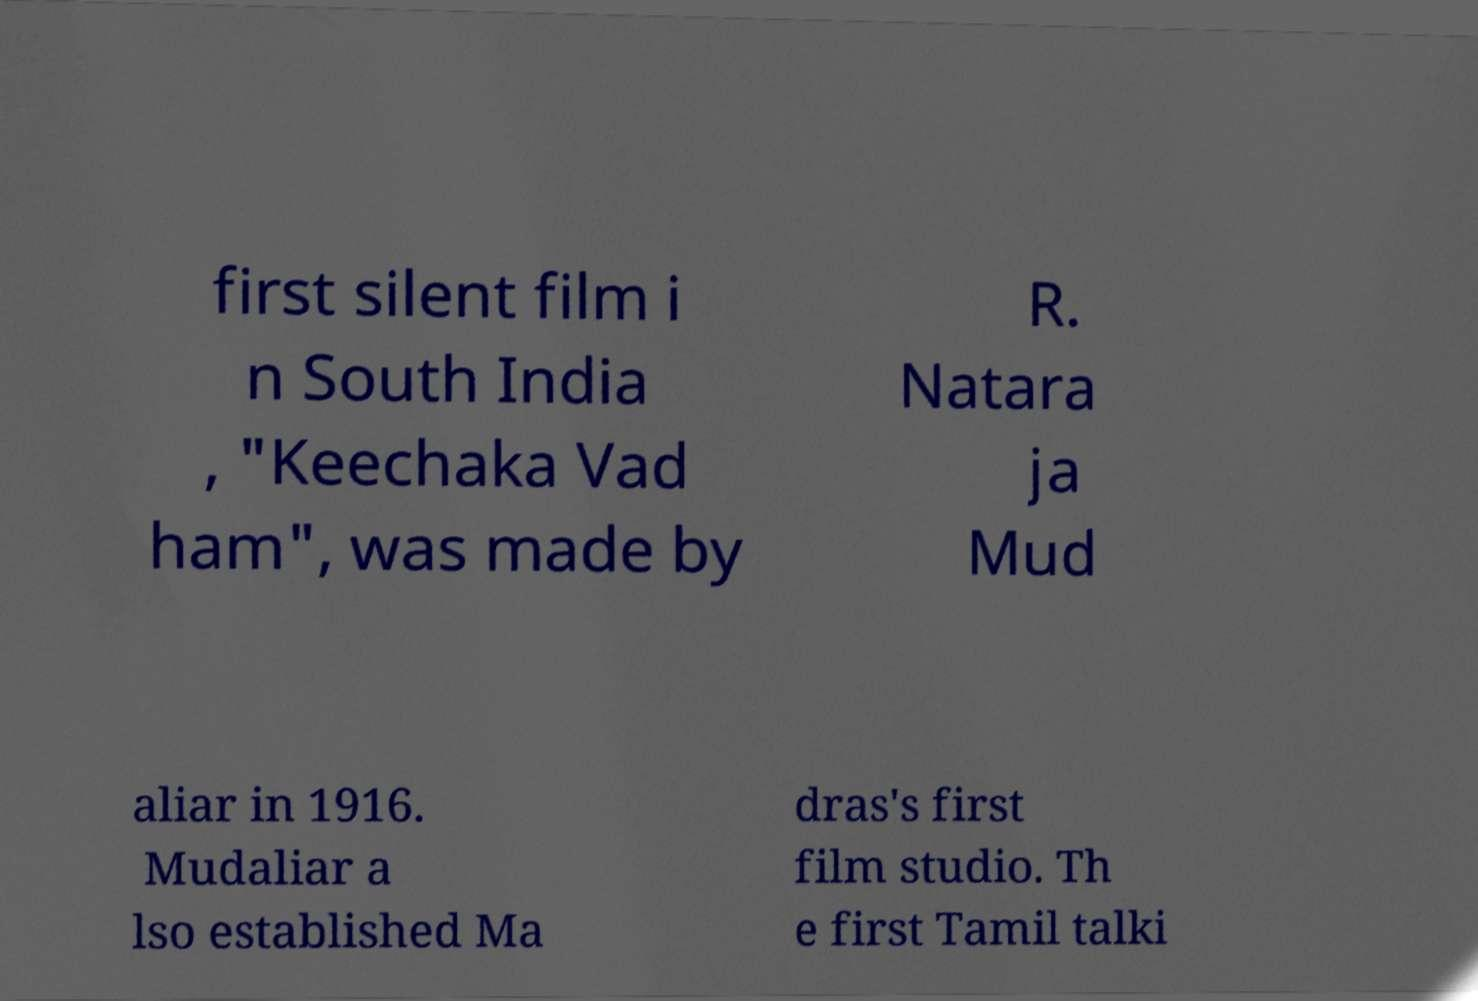Please identify and transcribe the text found in this image. first silent film i n South India , "Keechaka Vad ham", was made by R. Natara ja Mud aliar in 1916. Mudaliar a lso established Ma dras's first film studio. Th e first Tamil talki 